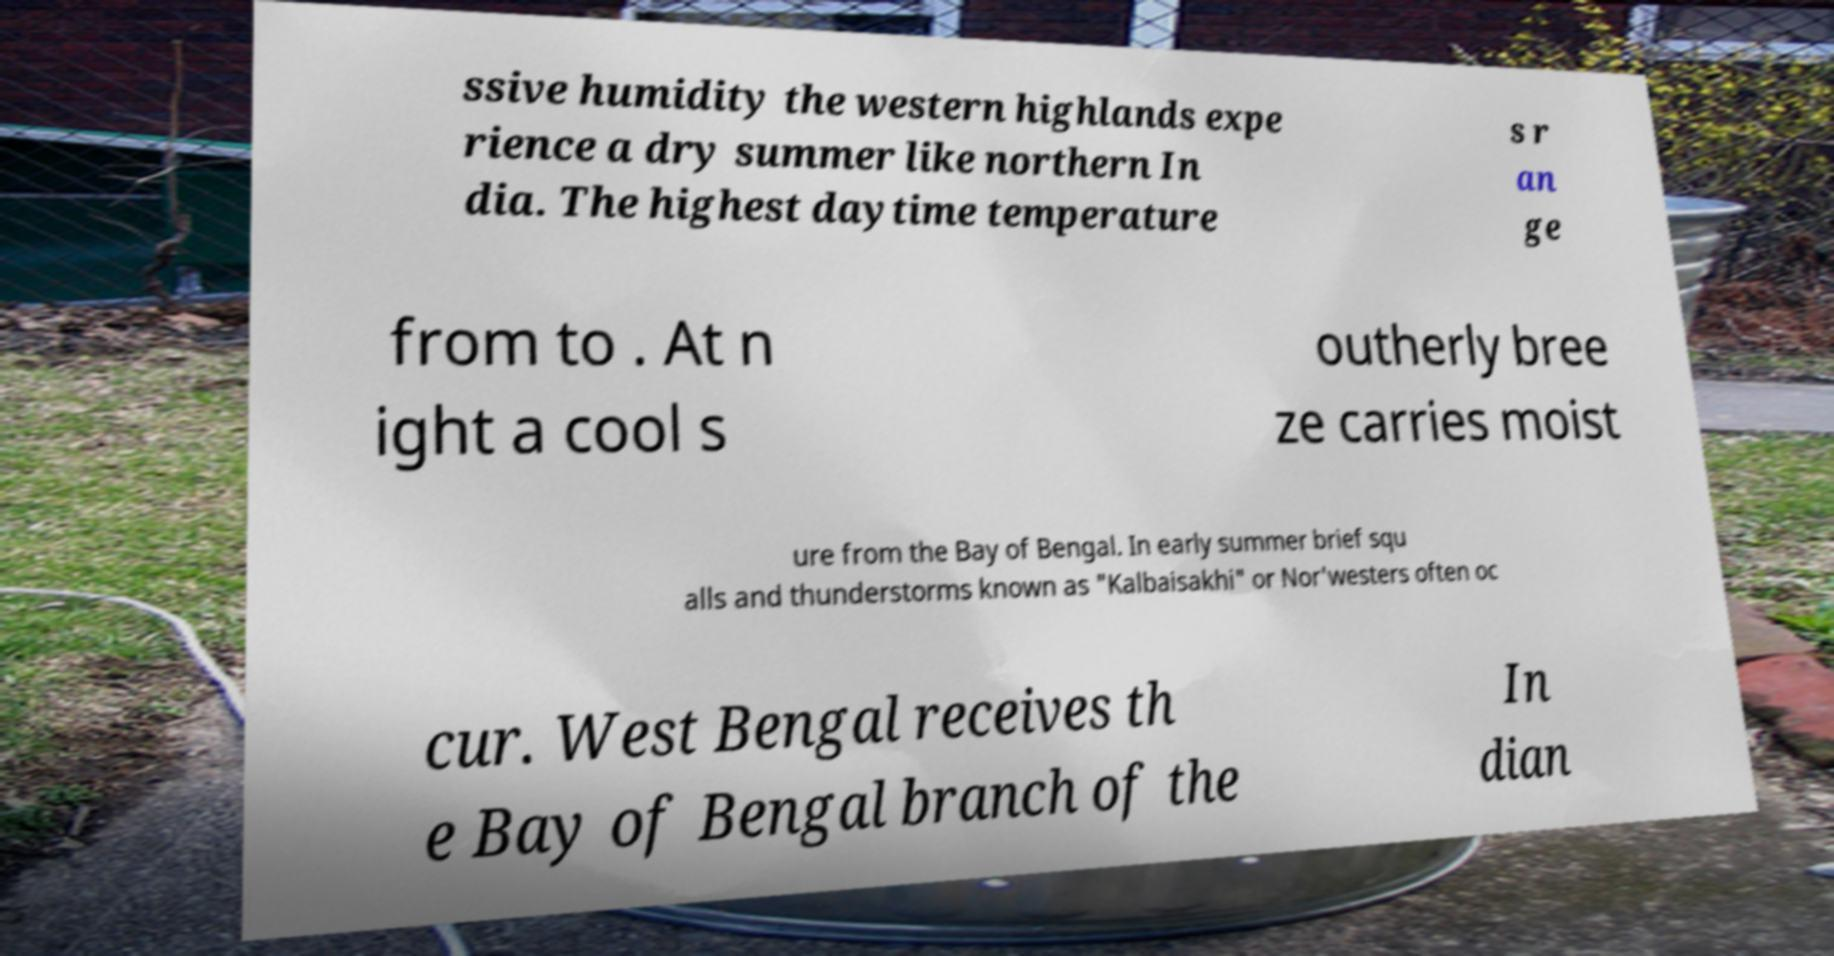For documentation purposes, I need the text within this image transcribed. Could you provide that? ssive humidity the western highlands expe rience a dry summer like northern In dia. The highest daytime temperature s r an ge from to . At n ight a cool s outherly bree ze carries moist ure from the Bay of Bengal. In early summer brief squ alls and thunderstorms known as "Kalbaisakhi" or Nor'westers often oc cur. West Bengal receives th e Bay of Bengal branch of the In dian 